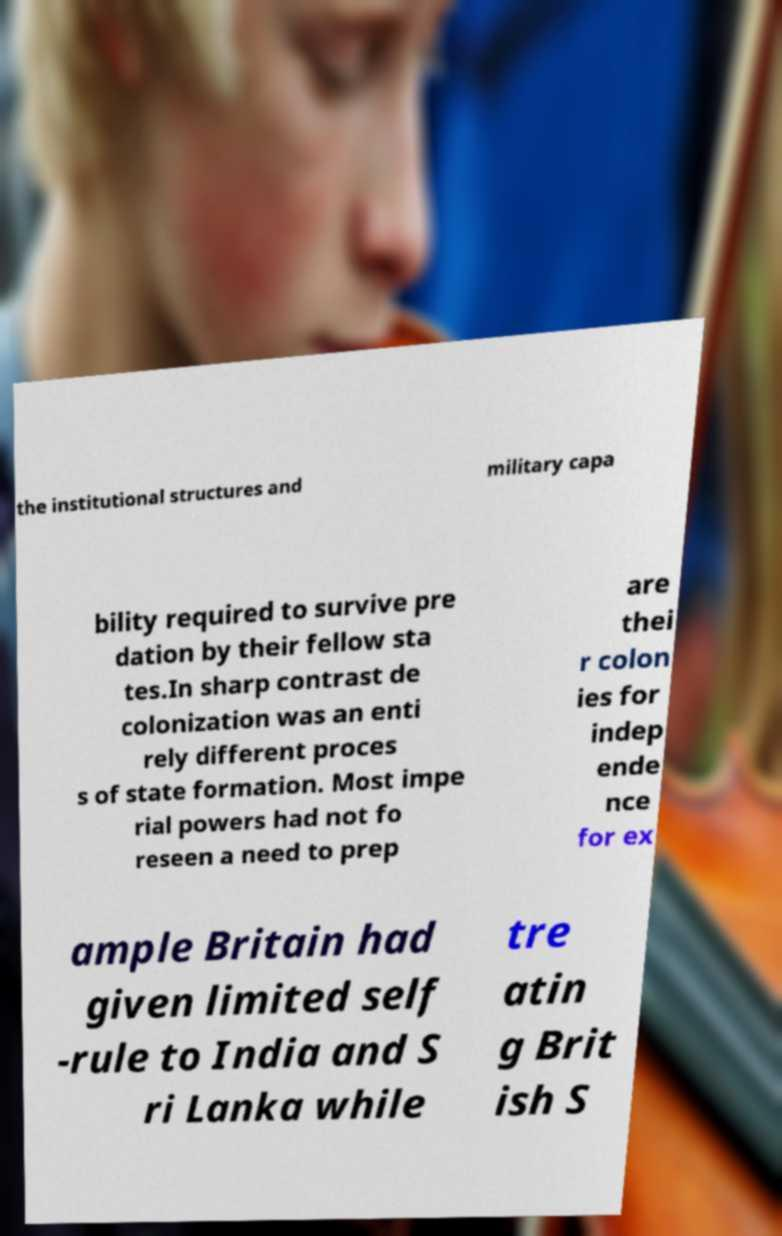Can you accurately transcribe the text from the provided image for me? the institutional structures and military capa bility required to survive pre dation by their fellow sta tes.In sharp contrast de colonization was an enti rely different proces s of state formation. Most impe rial powers had not fo reseen a need to prep are thei r colon ies for indep ende nce for ex ample Britain had given limited self -rule to India and S ri Lanka while tre atin g Brit ish S 